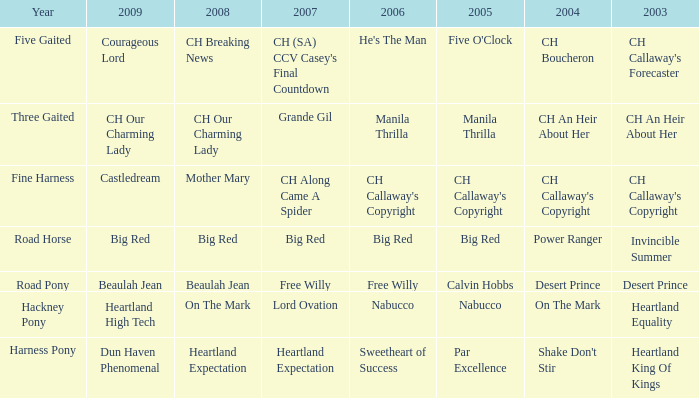When was the 2007 big red created? Road Horse. 